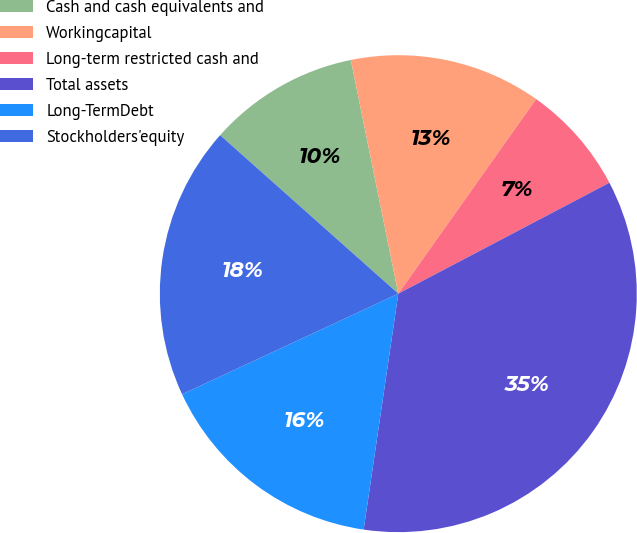Convert chart. <chart><loc_0><loc_0><loc_500><loc_500><pie_chart><fcel>Cash and cash equivalents and<fcel>Workingcapital<fcel>Long-term restricted cash and<fcel>Total assets<fcel>Long-TermDebt<fcel>Stockholders'equity<nl><fcel>10.24%<fcel>13.0%<fcel>7.49%<fcel>35.02%<fcel>15.75%<fcel>18.5%<nl></chart> 